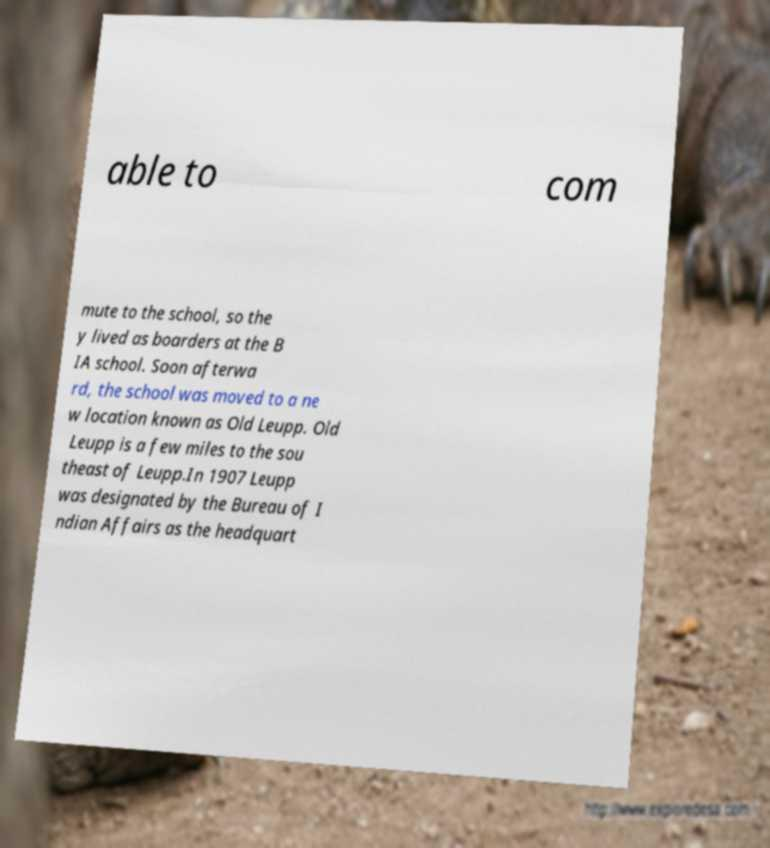Can you accurately transcribe the text from the provided image for me? able to com mute to the school, so the y lived as boarders at the B IA school. Soon afterwa rd, the school was moved to a ne w location known as Old Leupp. Old Leupp is a few miles to the sou theast of Leupp.In 1907 Leupp was designated by the Bureau of I ndian Affairs as the headquart 